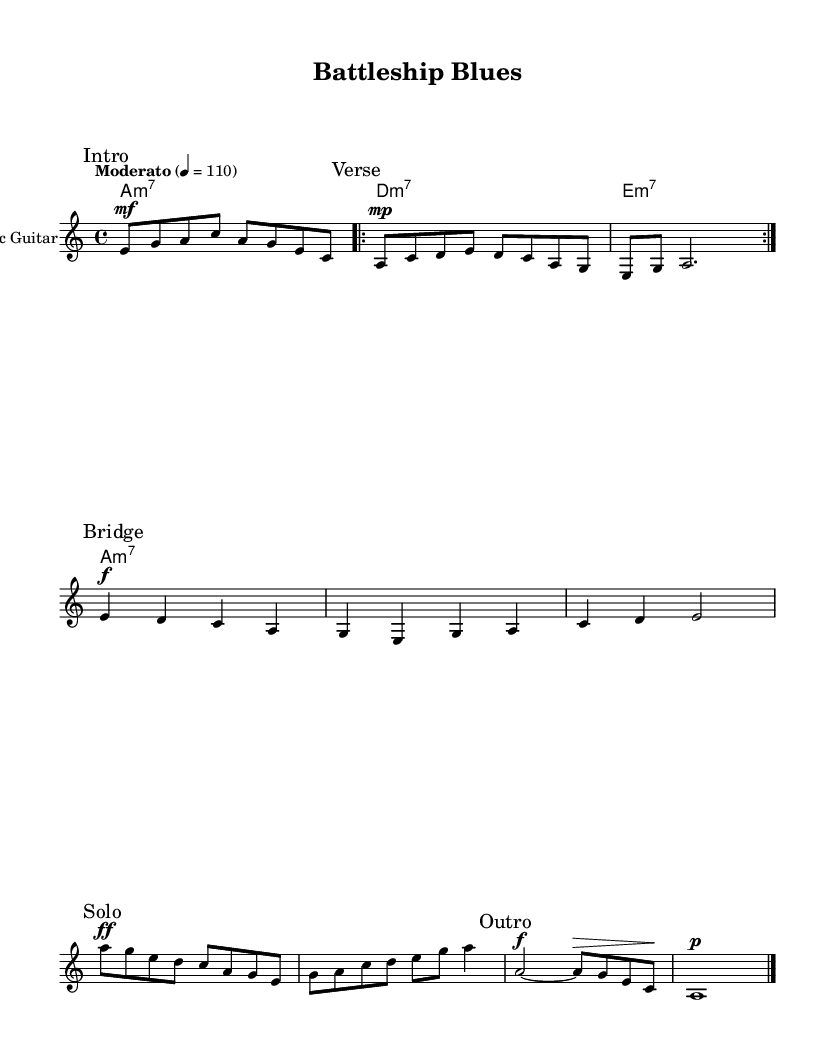What is the key signature of this music? The music is in A minor, which has no sharps or flats. This is indicated at the beginning of the sheet music before the staff lines.
Answer: A minor What is the time signature of "Battleship Blues"? The time signature is 4/4, which means there are four beats in each measure. This is shown at the start of the music, just after the key signature.
Answer: 4/4 What tempo marking is indicated for this piece? The tempo marking is "Moderato" at a speed of 110 beats per minute. This provides guidance on how fast the piece should be played and can be found near the beginning of the score.
Answer: Moderato 4 = 110 How many times is the verse section repeated? The verse section is marked as a repeat with "volta 2," indicating that it should be played two times before moving on. The repeat signs are denoted in the notation for the verse.
Answer: 2 In which section does the solo occur? The "Solo" section is explicitly marked within the score, indicating where the solo begins and showcases individual expression. This section comes after the bridge section.
Answer: Solo What dynamics are indicated for the solo section? The solo section starts with a "ff" (forte, meaning loud) dynamic marking, suggesting a strong and powerful performance. The dynamics indicate how the performer should vary the volume while playing.
Answer: ff What type of chords are used throughout the piece? The piece uses minor seventh chords, as indicated by the chord names written above the staff. This adds to the characteristic sound of electric blues music, which often features these types of chords.
Answer: minor seventh 